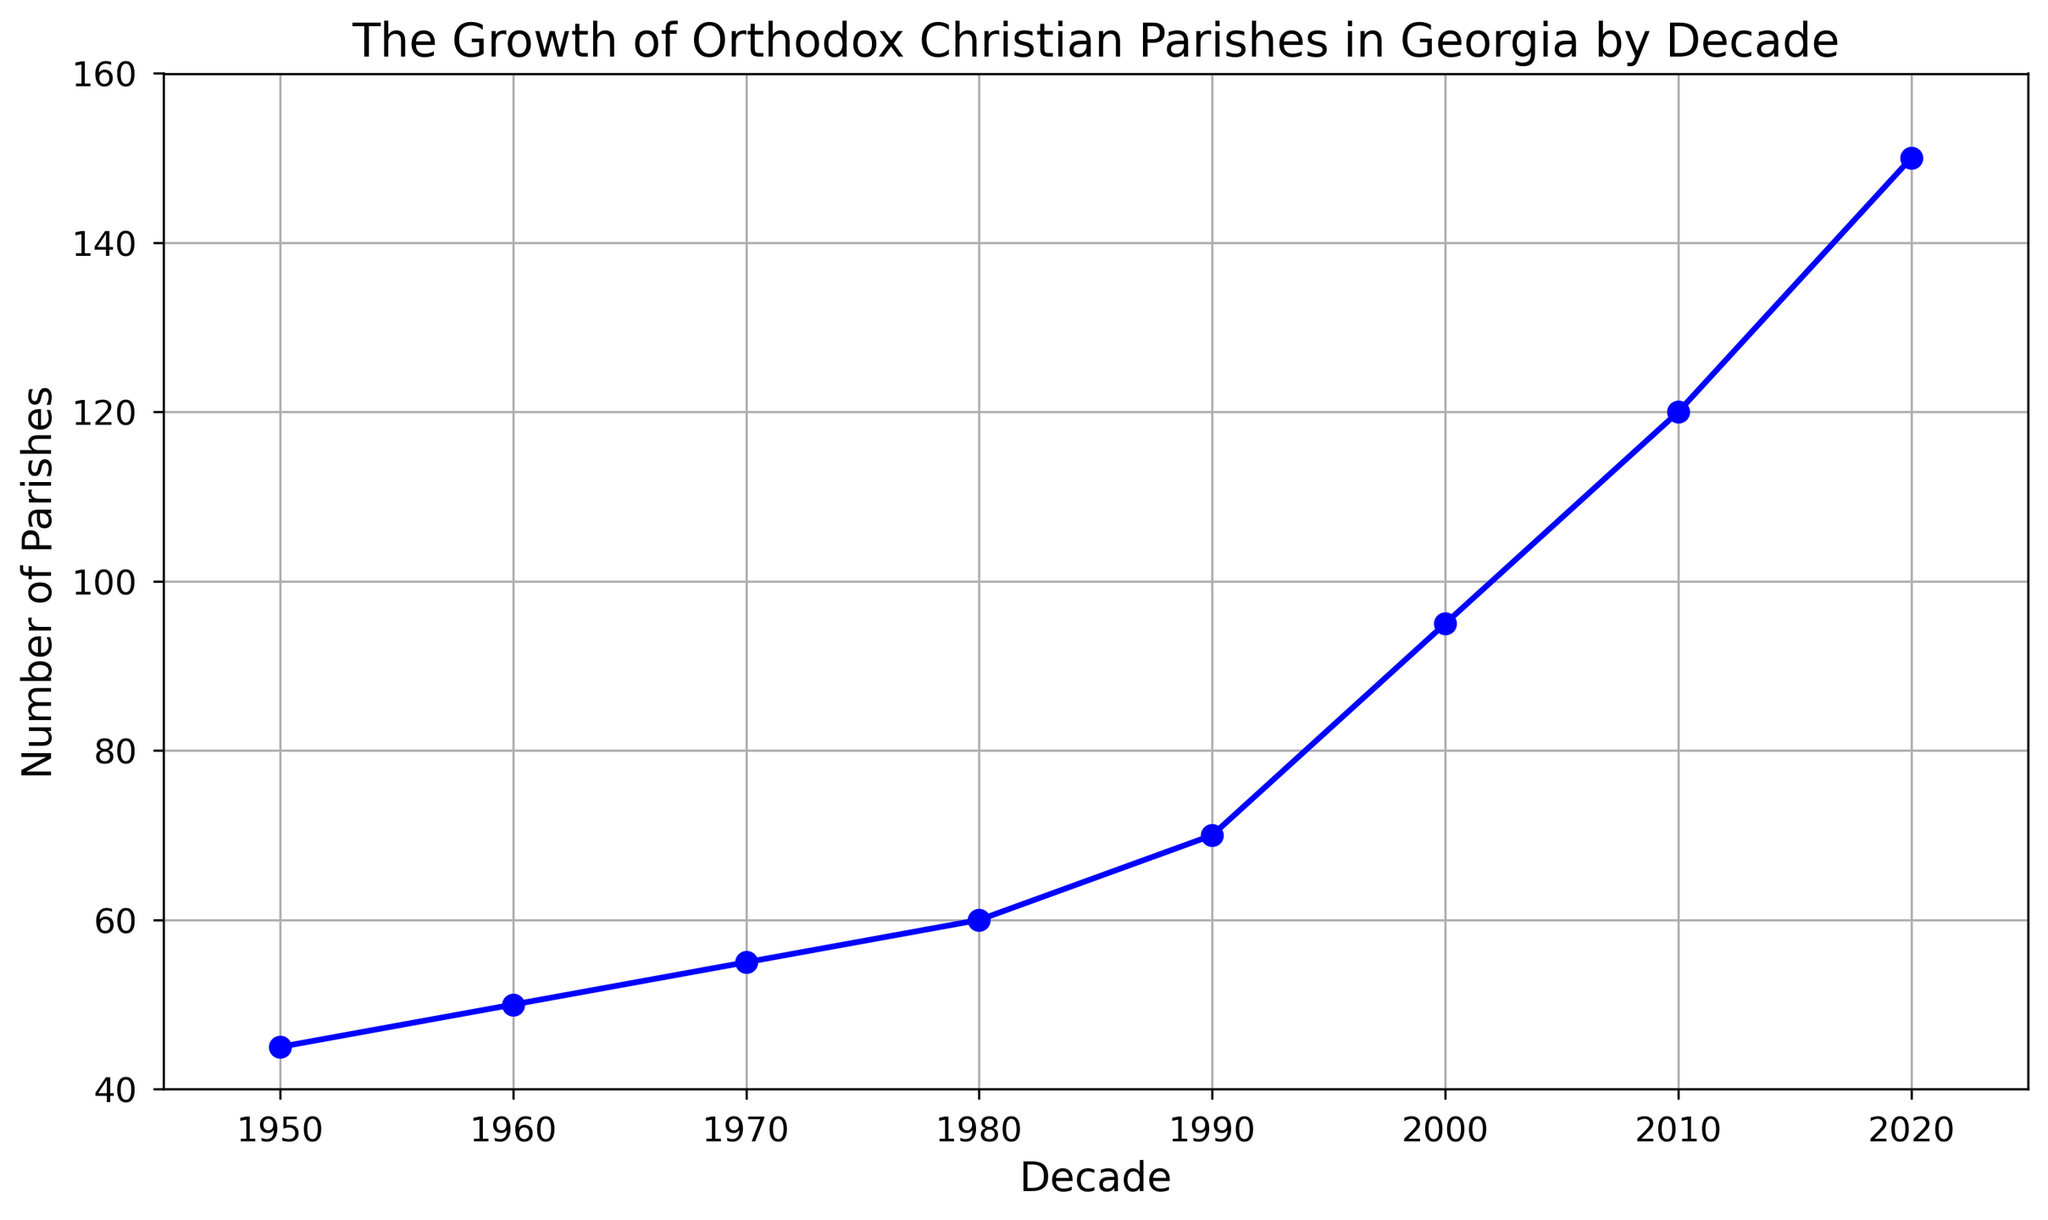What is the total increase in the number of parishes from 1950 to 2020? Starting in 1950, there were 45 parishes. By 2020, there were 150 parishes. The total increase is 150 - 45 = 105.
Answer: 105 Which decade saw the greatest increase in the number of parishes? The increases per decade are: 1960 (50-45=5), 1970 (55-50=5), 1980 (60-55=5), 1990 (70-60=10), 2000 (95-70=25), 2010 (120-95=25), 2020 (150-120=30). The greatest increase is from 2010 to 2020 with an increase of 30.
Answer: 2010 to 2020 How many more parishes were there in the year 2000 compared to 1980? In 1980, there were 60 parishes; in 2000, there were 95. The difference is 95 - 60 = 35.
Answer: 35 What is the average number of parishes over the decades shown? Add the number of parishes for each decade: 45 + 50 + 55 + 60 + 70 + 95 + 120 + 150 = 645. There are 8 decades, so the average is 645 / 8 = 80.625.
Answer: 80.625 By how much did the number of parishes increase on average per decade? Total increase from 1950 to 2020 is 105. There are 7 intervals between the 8 decades (2020-1950). The average increase per decade is 105 / 7 ≈ 15.
Answer: 15 In which decade was the number of parishes exactly 1 more than the previous decade? Look at the differences: 1960-1950 = 5, 1970-1960 = 5, 1980-1970 = 5, 1990-1980 = 10, 2000-1990 = 25, 2010-2000 = 25, 2020-2010 = 30. None of the differences are exactly 1.
Answer: None How many decades had an increase of parishes greater than or equal to 10? Increases of 10 or more: 1990 (10), 2000 (25), 2010 (25), 2020 (30). There are 4 such decades.
Answer: 4 What was the trend of parish growth from 1950 to 2020? From 1950 to 2020, the number of parishes increased steadily. The growth accelerated particularly after 1980.
Answer: Steady increase with acceleration after 1980 Compare the number of parishes in 1970 and 2000. In 1970, there were 55 parishes. In 2000, there were 95. There were 40 more parishes in 2000.
Answer: 40 more in 2000 What was the number of parishes in 1990? According to the figure, the number of parishes in 1990 was 70.
Answer: 70 